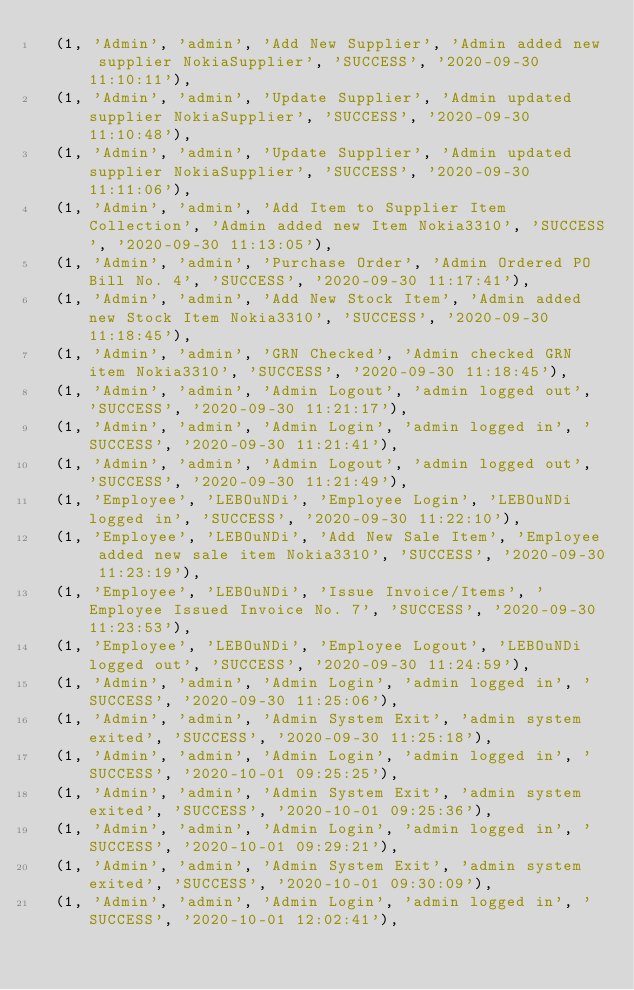<code> <loc_0><loc_0><loc_500><loc_500><_SQL_>	(1, 'Admin', 'admin', 'Add New Supplier', 'Admin added new supplier NokiaSupplier', 'SUCCESS', '2020-09-30 11:10:11'),
	(1, 'Admin', 'admin', 'Update Supplier', 'Admin updated supplier NokiaSupplier', 'SUCCESS', '2020-09-30 11:10:48'),
	(1, 'Admin', 'admin', 'Update Supplier', 'Admin updated supplier NokiaSupplier', 'SUCCESS', '2020-09-30 11:11:06'),
	(1, 'Admin', 'admin', 'Add Item to Supplier Item Collection', 'Admin added new Item Nokia3310', 'SUCCESS', '2020-09-30 11:13:05'),
	(1, 'Admin', 'admin', 'Purchase Order', 'Admin Ordered PO Bill No. 4', 'SUCCESS', '2020-09-30 11:17:41'),
	(1, 'Admin', 'admin', 'Add New Stock Item', 'Admin added new Stock Item Nokia3310', 'SUCCESS', '2020-09-30 11:18:45'),
	(1, 'Admin', 'admin', 'GRN Checked', 'Admin checked GRN item Nokia3310', 'SUCCESS', '2020-09-30 11:18:45'),
	(1, 'Admin', 'admin', 'Admin Logout', 'admin logged out', 'SUCCESS', '2020-09-30 11:21:17'),
	(1, 'Admin', 'admin', 'Admin Login', 'admin logged in', 'SUCCESS', '2020-09-30 11:21:41'),
	(1, 'Admin', 'admin', 'Admin Logout', 'admin logged out', 'SUCCESS', '2020-09-30 11:21:49'),
	(1, 'Employee', 'LEBOuNDi', 'Employee Login', 'LEBOuNDi logged in', 'SUCCESS', '2020-09-30 11:22:10'),
	(1, 'Employee', 'LEBOuNDi', 'Add New Sale Item', 'Employee added new sale item Nokia3310', 'SUCCESS', '2020-09-30 11:23:19'),
	(1, 'Employee', 'LEBOuNDi', 'Issue Invoice/Items', 'Employee Issued Invoice No. 7', 'SUCCESS', '2020-09-30 11:23:53'),
	(1, 'Employee', 'LEBOuNDi', 'Employee Logout', 'LEBOuNDi logged out', 'SUCCESS', '2020-09-30 11:24:59'),
	(1, 'Admin', 'admin', 'Admin Login', 'admin logged in', 'SUCCESS', '2020-09-30 11:25:06'),
	(1, 'Admin', 'admin', 'Admin System Exit', 'admin system exited', 'SUCCESS', '2020-09-30 11:25:18'),
	(1, 'Admin', 'admin', 'Admin Login', 'admin logged in', 'SUCCESS', '2020-10-01 09:25:25'),
	(1, 'Admin', 'admin', 'Admin System Exit', 'admin system exited', 'SUCCESS', '2020-10-01 09:25:36'),
	(1, 'Admin', 'admin', 'Admin Login', 'admin logged in', 'SUCCESS', '2020-10-01 09:29:21'),
	(1, 'Admin', 'admin', 'Admin System Exit', 'admin system exited', 'SUCCESS', '2020-10-01 09:30:09'),
	(1, 'Admin', 'admin', 'Admin Login', 'admin logged in', 'SUCCESS', '2020-10-01 12:02:41'),</code> 